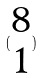<formula> <loc_0><loc_0><loc_500><loc_500>( \begin{matrix} 8 \\ 1 \end{matrix} )</formula> 